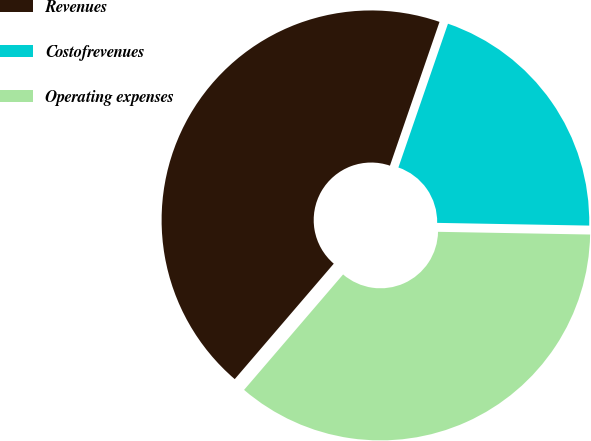Convert chart. <chart><loc_0><loc_0><loc_500><loc_500><pie_chart><fcel>Revenues<fcel>Costofrevenues<fcel>Operating expenses<nl><fcel>44.0%<fcel>20.0%<fcel>36.0%<nl></chart> 